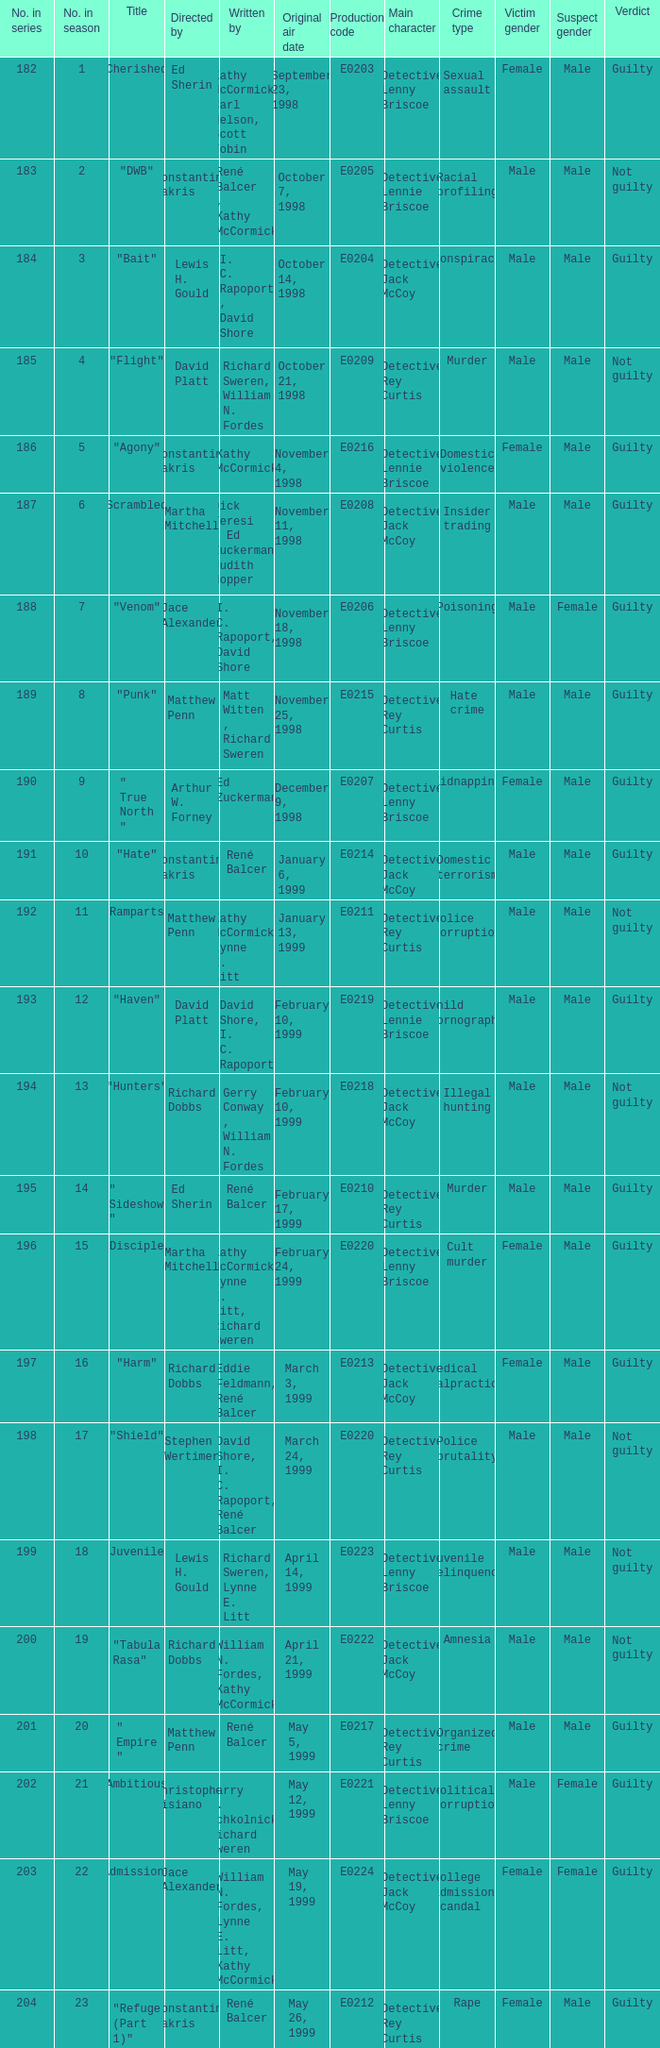The episode with original air date January 13, 1999 is written by who? Kathy McCormick, Lynne E. Litt. 